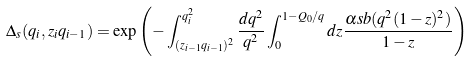<formula> <loc_0><loc_0><loc_500><loc_500>\Delta _ { s } ( q _ { i } , z _ { i } q _ { i - 1 } ) = \exp { \left ( - \int _ { ( z _ { i - 1 } q _ { i - 1 } ) ^ { 2 } } ^ { q ^ { 2 } _ { i } } \frac { d q ^ { 2 } } { q ^ { 2 } } \int _ { 0 } ^ { 1 - Q _ { 0 } / q } d z \frac { \alpha s b ( q ^ { 2 } ( 1 - z ) ^ { 2 } ) } { 1 - z } \right ) }</formula> 